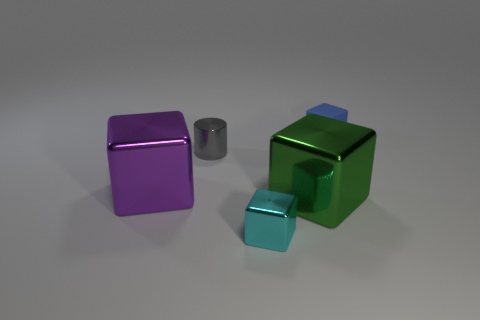Add 3 tiny gray things. How many objects exist? 8 Subtract all cylinders. How many objects are left? 4 Subtract all red cylinders. Subtract all cyan things. How many objects are left? 4 Add 5 tiny metal objects. How many tiny metal objects are left? 7 Add 5 small green balls. How many small green balls exist? 5 Subtract 0 yellow cubes. How many objects are left? 5 